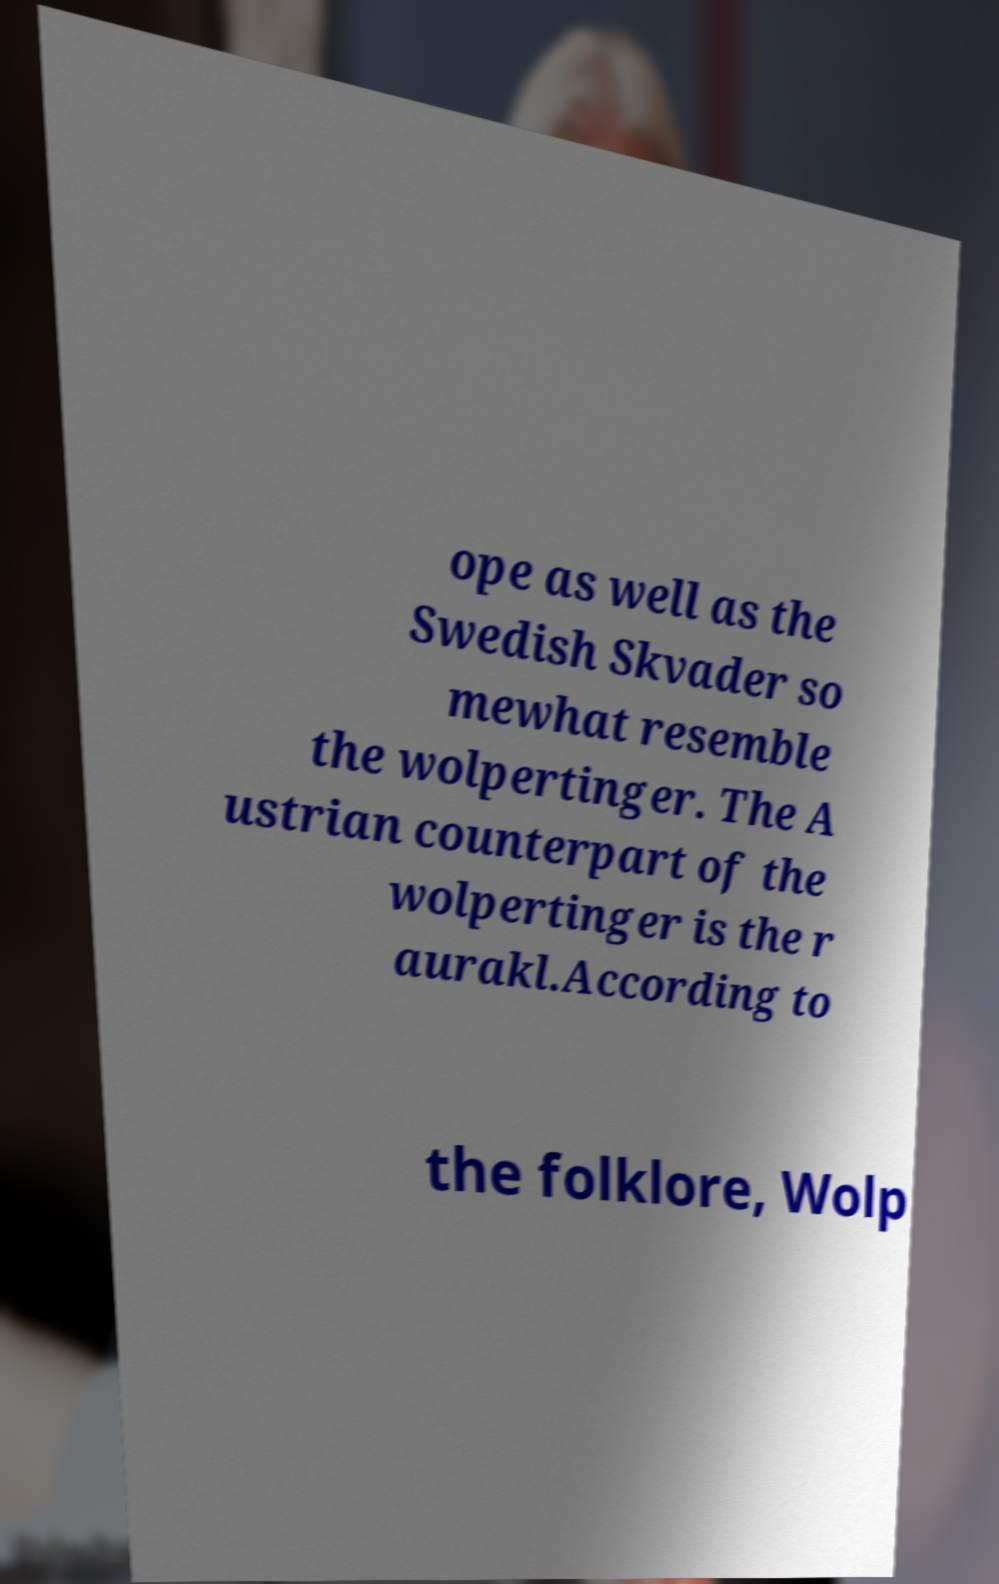What messages or text are displayed in this image? I need them in a readable, typed format. ope as well as the Swedish Skvader so mewhat resemble the wolpertinger. The A ustrian counterpart of the wolpertinger is the r aurakl.According to the folklore, Wolp 